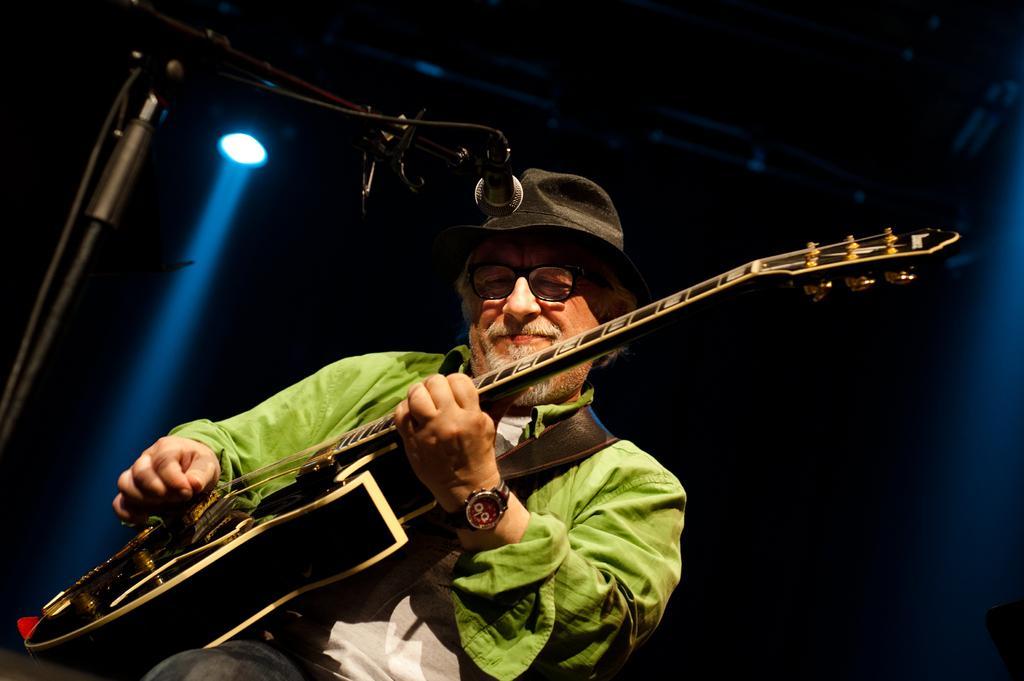How would you summarize this image in a sentence or two? In the image we see there is a person who is holding guitar in his hand and he is wearing a wrist watch and a black hat. 